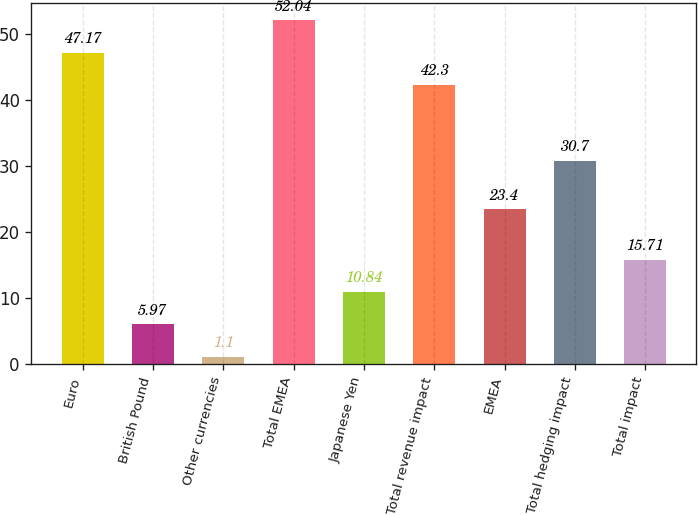Convert chart to OTSL. <chart><loc_0><loc_0><loc_500><loc_500><bar_chart><fcel>Euro<fcel>British Pound<fcel>Other currencies<fcel>Total EMEA<fcel>Japanese Yen<fcel>Total revenue impact<fcel>EMEA<fcel>Total hedging impact<fcel>Total impact<nl><fcel>47.17<fcel>5.97<fcel>1.1<fcel>52.04<fcel>10.84<fcel>42.3<fcel>23.4<fcel>30.7<fcel>15.71<nl></chart> 